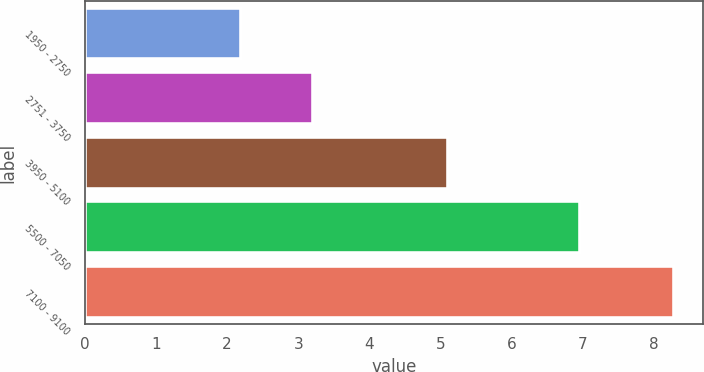Convert chart to OTSL. <chart><loc_0><loc_0><loc_500><loc_500><bar_chart><fcel>1950 - 2750<fcel>2751 - 3750<fcel>3950 - 5100<fcel>5500 - 7050<fcel>7100 - 9100<nl><fcel>2.2<fcel>3.21<fcel>5.1<fcel>6.96<fcel>8.28<nl></chart> 